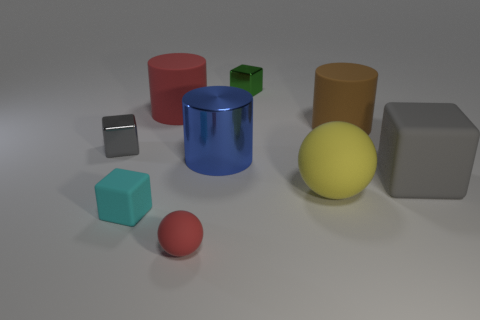The matte object that is the same color as the small ball is what shape? cylinder 